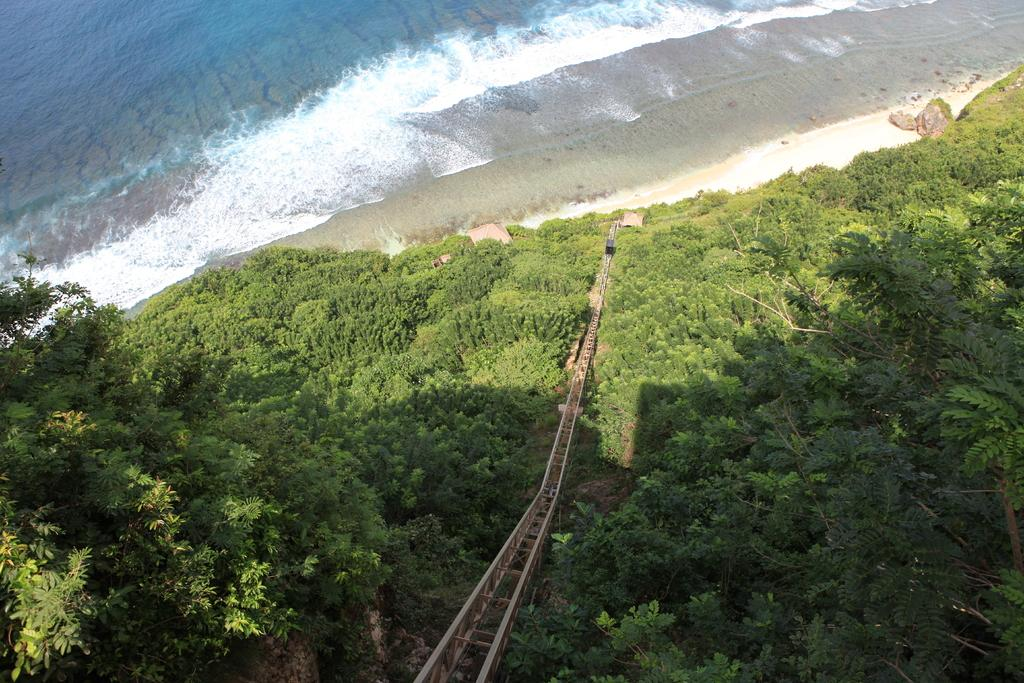What is the main structure in the center of the image? There is a bridge in the center of the image. What can be seen in the background of the image? There are trees and rocks in the background. What is visible in the image besides the bridge and background? There is water visible in the image. How many tomatoes are growing on the bridge in the image? There are no tomatoes present in the image, as it features a bridge, trees, rocks, and water. Can you see a yam being harvested from the rocks in the background? There is no yam present in the image, and the rocks in the background do not show any signs of harvesting. 